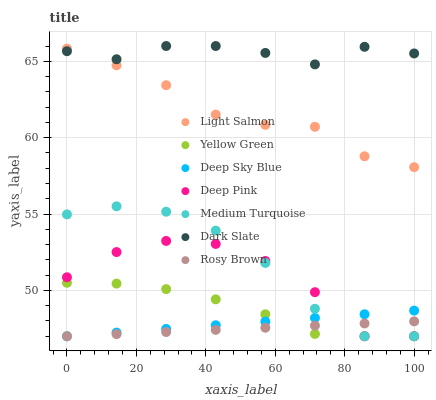Does Rosy Brown have the minimum area under the curve?
Answer yes or no. Yes. Does Dark Slate have the maximum area under the curve?
Answer yes or no. Yes. Does Deep Pink have the minimum area under the curve?
Answer yes or no. No. Does Deep Pink have the maximum area under the curve?
Answer yes or no. No. Is Deep Sky Blue the smoothest?
Answer yes or no. Yes. Is Deep Pink the roughest?
Answer yes or no. Yes. Is Yellow Green the smoothest?
Answer yes or no. No. Is Yellow Green the roughest?
Answer yes or no. No. Does Deep Pink have the lowest value?
Answer yes or no. Yes. Does Dark Slate have the lowest value?
Answer yes or no. No. Does Dark Slate have the highest value?
Answer yes or no. Yes. Does Deep Pink have the highest value?
Answer yes or no. No. Is Rosy Brown less than Dark Slate?
Answer yes or no. Yes. Is Light Salmon greater than Deep Pink?
Answer yes or no. Yes. Does Deep Sky Blue intersect Medium Turquoise?
Answer yes or no. Yes. Is Deep Sky Blue less than Medium Turquoise?
Answer yes or no. No. Is Deep Sky Blue greater than Medium Turquoise?
Answer yes or no. No. Does Rosy Brown intersect Dark Slate?
Answer yes or no. No. 